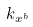Convert formula to latex. <formula><loc_0><loc_0><loc_500><loc_500>k _ { x ^ { b } }</formula> 